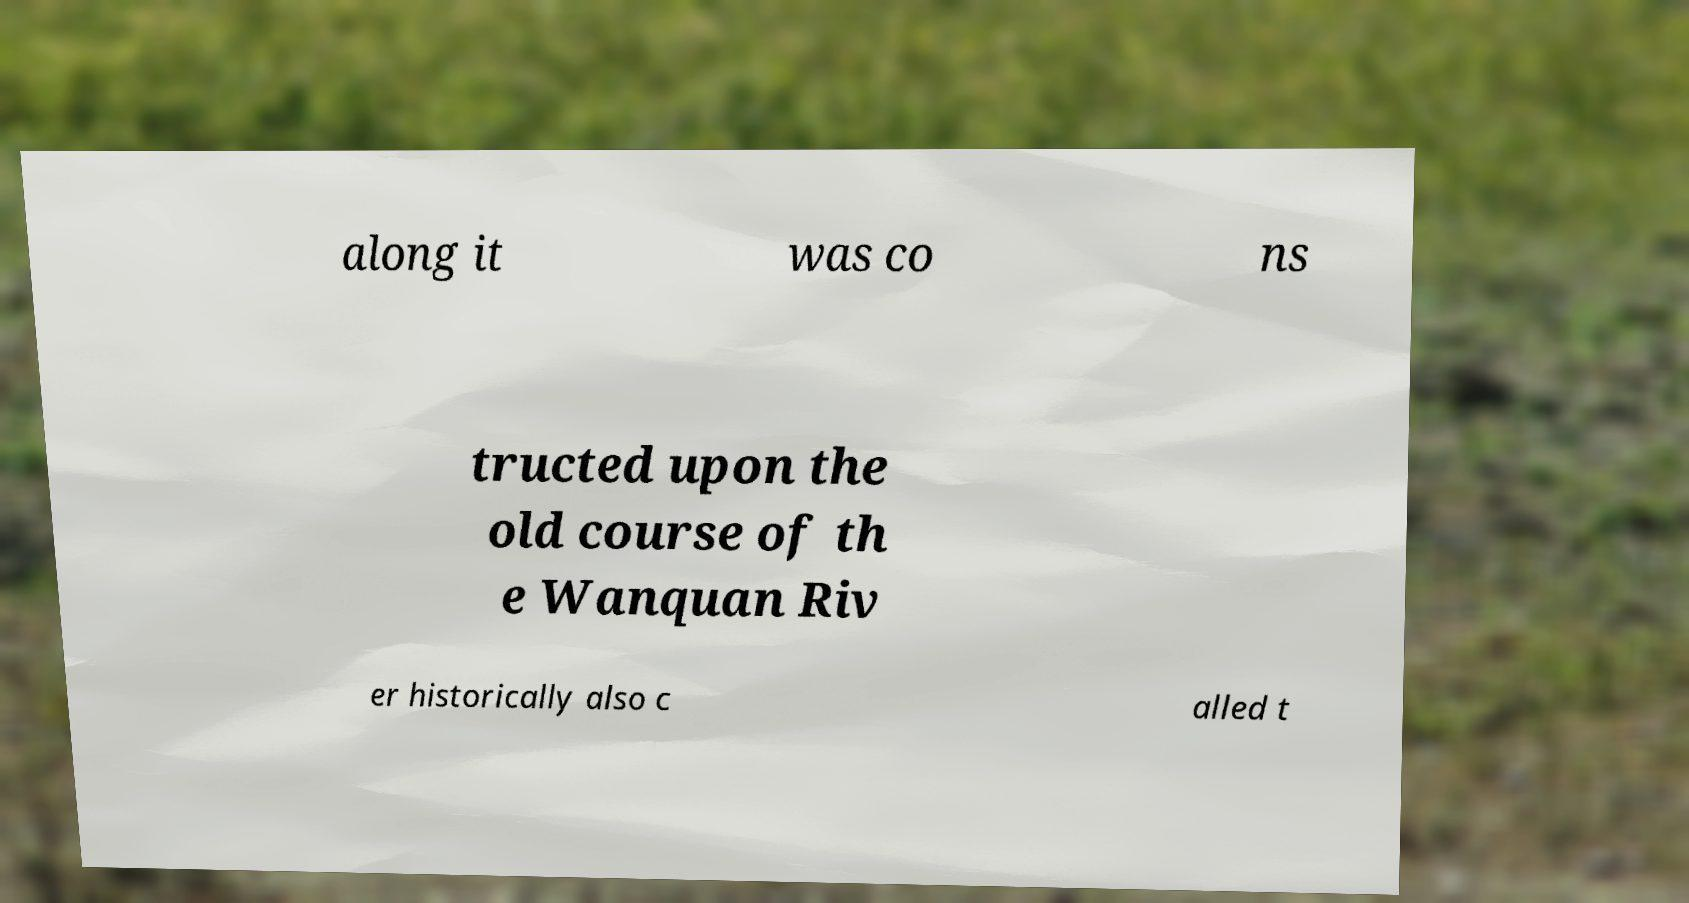Can you accurately transcribe the text from the provided image for me? along it was co ns tructed upon the old course of th e Wanquan Riv er historically also c alled t 